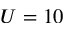<formula> <loc_0><loc_0><loc_500><loc_500>U = 1 0</formula> 